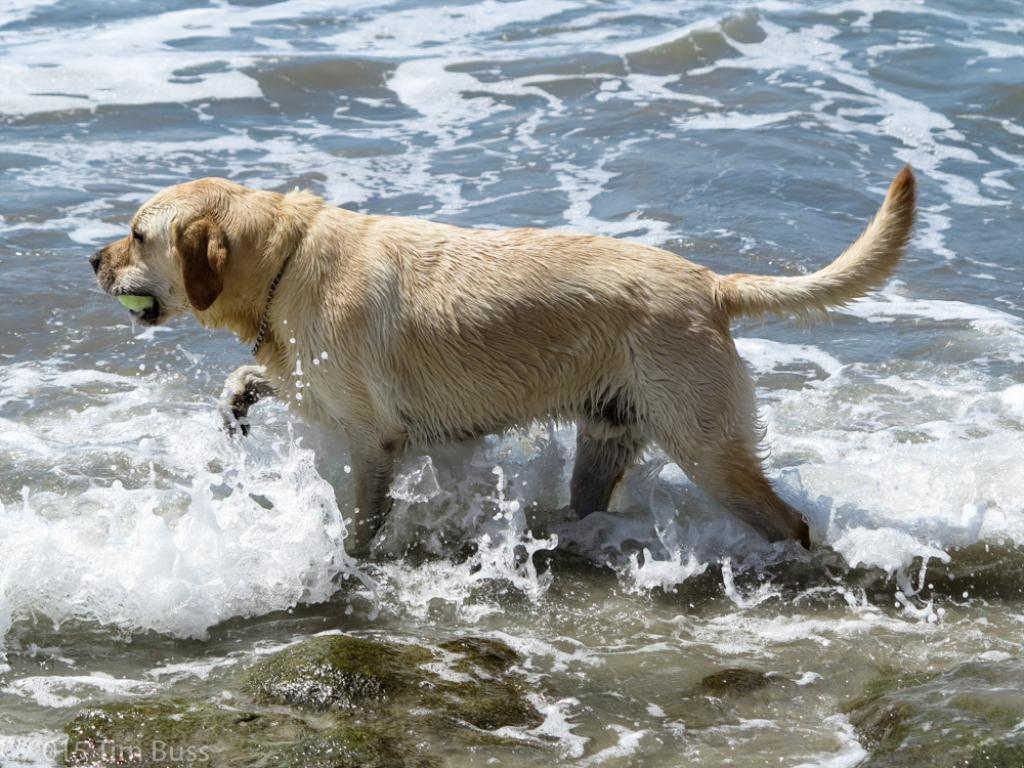What animal can be seen in the image? There is a dog in the image. What is the dog doing in the image? The dog is walking in the water. What object is the dog holding in its mouth? The dog is holding a ball in its mouth. What type of terrain is visible in the image? There are stones visible in the image. Where can the chickens be found in the image? There are no chickens present in the image. What type of curtain is hanging near the dog in the image? There is no curtain visible in the image. 